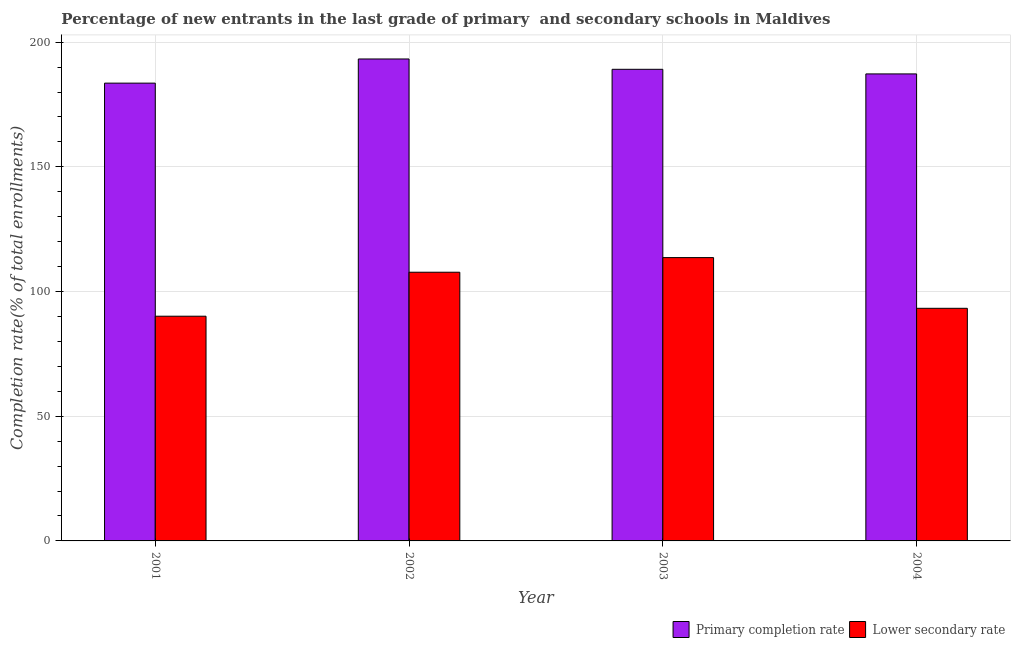How many different coloured bars are there?
Provide a succinct answer. 2. Are the number of bars per tick equal to the number of legend labels?
Your response must be concise. Yes. Are the number of bars on each tick of the X-axis equal?
Make the answer very short. Yes. How many bars are there on the 2nd tick from the left?
Ensure brevity in your answer.  2. What is the label of the 3rd group of bars from the left?
Your answer should be very brief. 2003. What is the completion rate in primary schools in 2001?
Provide a succinct answer. 183.57. Across all years, what is the maximum completion rate in secondary schools?
Offer a very short reply. 113.61. Across all years, what is the minimum completion rate in secondary schools?
Provide a succinct answer. 90.11. In which year was the completion rate in secondary schools minimum?
Offer a very short reply. 2001. What is the total completion rate in secondary schools in the graph?
Your response must be concise. 404.75. What is the difference between the completion rate in primary schools in 2002 and that in 2003?
Give a very brief answer. 4.15. What is the difference between the completion rate in primary schools in 2003 and the completion rate in secondary schools in 2004?
Provide a short and direct response. 1.85. What is the average completion rate in primary schools per year?
Your answer should be compact. 188.31. What is the ratio of the completion rate in primary schools in 2003 to that in 2004?
Your response must be concise. 1.01. Is the completion rate in primary schools in 2003 less than that in 2004?
Ensure brevity in your answer.  No. Is the difference between the completion rate in secondary schools in 2001 and 2003 greater than the difference between the completion rate in primary schools in 2001 and 2003?
Give a very brief answer. No. What is the difference between the highest and the second highest completion rate in primary schools?
Give a very brief answer. 4.15. What is the difference between the highest and the lowest completion rate in primary schools?
Provide a short and direct response. 9.69. What does the 2nd bar from the left in 2004 represents?
Provide a short and direct response. Lower secondary rate. What does the 2nd bar from the right in 2001 represents?
Make the answer very short. Primary completion rate. How many bars are there?
Keep it short and to the point. 8. How many years are there in the graph?
Provide a short and direct response. 4. What is the difference between two consecutive major ticks on the Y-axis?
Offer a terse response. 50. Are the values on the major ticks of Y-axis written in scientific E-notation?
Your answer should be very brief. No. Does the graph contain any zero values?
Provide a short and direct response. No. Does the graph contain grids?
Provide a succinct answer. Yes. Where does the legend appear in the graph?
Your answer should be compact. Bottom right. How are the legend labels stacked?
Offer a very short reply. Horizontal. What is the title of the graph?
Your response must be concise. Percentage of new entrants in the last grade of primary  and secondary schools in Maldives. What is the label or title of the X-axis?
Offer a terse response. Year. What is the label or title of the Y-axis?
Make the answer very short. Completion rate(% of total enrollments). What is the Completion rate(% of total enrollments) of Primary completion rate in 2001?
Provide a short and direct response. 183.57. What is the Completion rate(% of total enrollments) in Lower secondary rate in 2001?
Give a very brief answer. 90.11. What is the Completion rate(% of total enrollments) in Primary completion rate in 2002?
Offer a very short reply. 193.26. What is the Completion rate(% of total enrollments) of Lower secondary rate in 2002?
Your answer should be compact. 107.75. What is the Completion rate(% of total enrollments) of Primary completion rate in 2003?
Your response must be concise. 189.12. What is the Completion rate(% of total enrollments) of Lower secondary rate in 2003?
Make the answer very short. 113.61. What is the Completion rate(% of total enrollments) of Primary completion rate in 2004?
Offer a very short reply. 187.27. What is the Completion rate(% of total enrollments) of Lower secondary rate in 2004?
Provide a succinct answer. 93.28. Across all years, what is the maximum Completion rate(% of total enrollments) of Primary completion rate?
Your answer should be compact. 193.26. Across all years, what is the maximum Completion rate(% of total enrollments) in Lower secondary rate?
Your response must be concise. 113.61. Across all years, what is the minimum Completion rate(% of total enrollments) in Primary completion rate?
Your response must be concise. 183.57. Across all years, what is the minimum Completion rate(% of total enrollments) of Lower secondary rate?
Provide a succinct answer. 90.11. What is the total Completion rate(% of total enrollments) in Primary completion rate in the graph?
Your answer should be compact. 753.22. What is the total Completion rate(% of total enrollments) of Lower secondary rate in the graph?
Keep it short and to the point. 404.75. What is the difference between the Completion rate(% of total enrollments) in Primary completion rate in 2001 and that in 2002?
Give a very brief answer. -9.69. What is the difference between the Completion rate(% of total enrollments) of Lower secondary rate in 2001 and that in 2002?
Your response must be concise. -17.64. What is the difference between the Completion rate(% of total enrollments) of Primary completion rate in 2001 and that in 2003?
Provide a succinct answer. -5.54. What is the difference between the Completion rate(% of total enrollments) in Lower secondary rate in 2001 and that in 2003?
Your answer should be very brief. -23.51. What is the difference between the Completion rate(% of total enrollments) in Primary completion rate in 2001 and that in 2004?
Ensure brevity in your answer.  -3.69. What is the difference between the Completion rate(% of total enrollments) in Lower secondary rate in 2001 and that in 2004?
Provide a short and direct response. -3.17. What is the difference between the Completion rate(% of total enrollments) of Primary completion rate in 2002 and that in 2003?
Provide a succinct answer. 4.15. What is the difference between the Completion rate(% of total enrollments) in Lower secondary rate in 2002 and that in 2003?
Offer a terse response. -5.86. What is the difference between the Completion rate(% of total enrollments) in Primary completion rate in 2002 and that in 2004?
Offer a terse response. 5.99. What is the difference between the Completion rate(% of total enrollments) of Lower secondary rate in 2002 and that in 2004?
Keep it short and to the point. 14.47. What is the difference between the Completion rate(% of total enrollments) of Primary completion rate in 2003 and that in 2004?
Your answer should be very brief. 1.85. What is the difference between the Completion rate(% of total enrollments) of Lower secondary rate in 2003 and that in 2004?
Provide a short and direct response. 20.33. What is the difference between the Completion rate(% of total enrollments) in Primary completion rate in 2001 and the Completion rate(% of total enrollments) in Lower secondary rate in 2002?
Offer a very short reply. 75.83. What is the difference between the Completion rate(% of total enrollments) of Primary completion rate in 2001 and the Completion rate(% of total enrollments) of Lower secondary rate in 2003?
Offer a terse response. 69.96. What is the difference between the Completion rate(% of total enrollments) in Primary completion rate in 2001 and the Completion rate(% of total enrollments) in Lower secondary rate in 2004?
Keep it short and to the point. 90.3. What is the difference between the Completion rate(% of total enrollments) in Primary completion rate in 2002 and the Completion rate(% of total enrollments) in Lower secondary rate in 2003?
Provide a succinct answer. 79.65. What is the difference between the Completion rate(% of total enrollments) of Primary completion rate in 2002 and the Completion rate(% of total enrollments) of Lower secondary rate in 2004?
Keep it short and to the point. 99.99. What is the difference between the Completion rate(% of total enrollments) of Primary completion rate in 2003 and the Completion rate(% of total enrollments) of Lower secondary rate in 2004?
Your answer should be very brief. 95.84. What is the average Completion rate(% of total enrollments) in Primary completion rate per year?
Give a very brief answer. 188.31. What is the average Completion rate(% of total enrollments) in Lower secondary rate per year?
Keep it short and to the point. 101.19. In the year 2001, what is the difference between the Completion rate(% of total enrollments) of Primary completion rate and Completion rate(% of total enrollments) of Lower secondary rate?
Give a very brief answer. 93.47. In the year 2002, what is the difference between the Completion rate(% of total enrollments) of Primary completion rate and Completion rate(% of total enrollments) of Lower secondary rate?
Offer a terse response. 85.52. In the year 2003, what is the difference between the Completion rate(% of total enrollments) in Primary completion rate and Completion rate(% of total enrollments) in Lower secondary rate?
Offer a very short reply. 75.51. In the year 2004, what is the difference between the Completion rate(% of total enrollments) in Primary completion rate and Completion rate(% of total enrollments) in Lower secondary rate?
Your response must be concise. 93.99. What is the ratio of the Completion rate(% of total enrollments) in Primary completion rate in 2001 to that in 2002?
Keep it short and to the point. 0.95. What is the ratio of the Completion rate(% of total enrollments) of Lower secondary rate in 2001 to that in 2002?
Offer a terse response. 0.84. What is the ratio of the Completion rate(% of total enrollments) in Primary completion rate in 2001 to that in 2003?
Offer a very short reply. 0.97. What is the ratio of the Completion rate(% of total enrollments) of Lower secondary rate in 2001 to that in 2003?
Offer a terse response. 0.79. What is the ratio of the Completion rate(% of total enrollments) of Primary completion rate in 2001 to that in 2004?
Make the answer very short. 0.98. What is the ratio of the Completion rate(% of total enrollments) of Lower secondary rate in 2001 to that in 2004?
Make the answer very short. 0.97. What is the ratio of the Completion rate(% of total enrollments) in Primary completion rate in 2002 to that in 2003?
Provide a short and direct response. 1.02. What is the ratio of the Completion rate(% of total enrollments) in Lower secondary rate in 2002 to that in 2003?
Give a very brief answer. 0.95. What is the ratio of the Completion rate(% of total enrollments) of Primary completion rate in 2002 to that in 2004?
Offer a very short reply. 1.03. What is the ratio of the Completion rate(% of total enrollments) in Lower secondary rate in 2002 to that in 2004?
Keep it short and to the point. 1.16. What is the ratio of the Completion rate(% of total enrollments) in Primary completion rate in 2003 to that in 2004?
Give a very brief answer. 1.01. What is the ratio of the Completion rate(% of total enrollments) in Lower secondary rate in 2003 to that in 2004?
Keep it short and to the point. 1.22. What is the difference between the highest and the second highest Completion rate(% of total enrollments) of Primary completion rate?
Your answer should be very brief. 4.15. What is the difference between the highest and the second highest Completion rate(% of total enrollments) in Lower secondary rate?
Offer a very short reply. 5.86. What is the difference between the highest and the lowest Completion rate(% of total enrollments) of Primary completion rate?
Your answer should be compact. 9.69. What is the difference between the highest and the lowest Completion rate(% of total enrollments) of Lower secondary rate?
Provide a succinct answer. 23.51. 